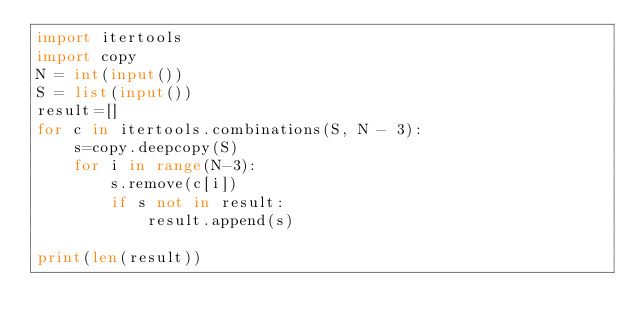Convert code to text. <code><loc_0><loc_0><loc_500><loc_500><_Python_>import itertools
import copy
N = int(input())
S = list(input())
result=[]
for c in itertools.combinations(S, N - 3):
    s=copy.deepcopy(S)
    for i in range(N-3):
        s.remove(c[i])
        if s not in result:
            result.append(s)

print(len(result))</code> 